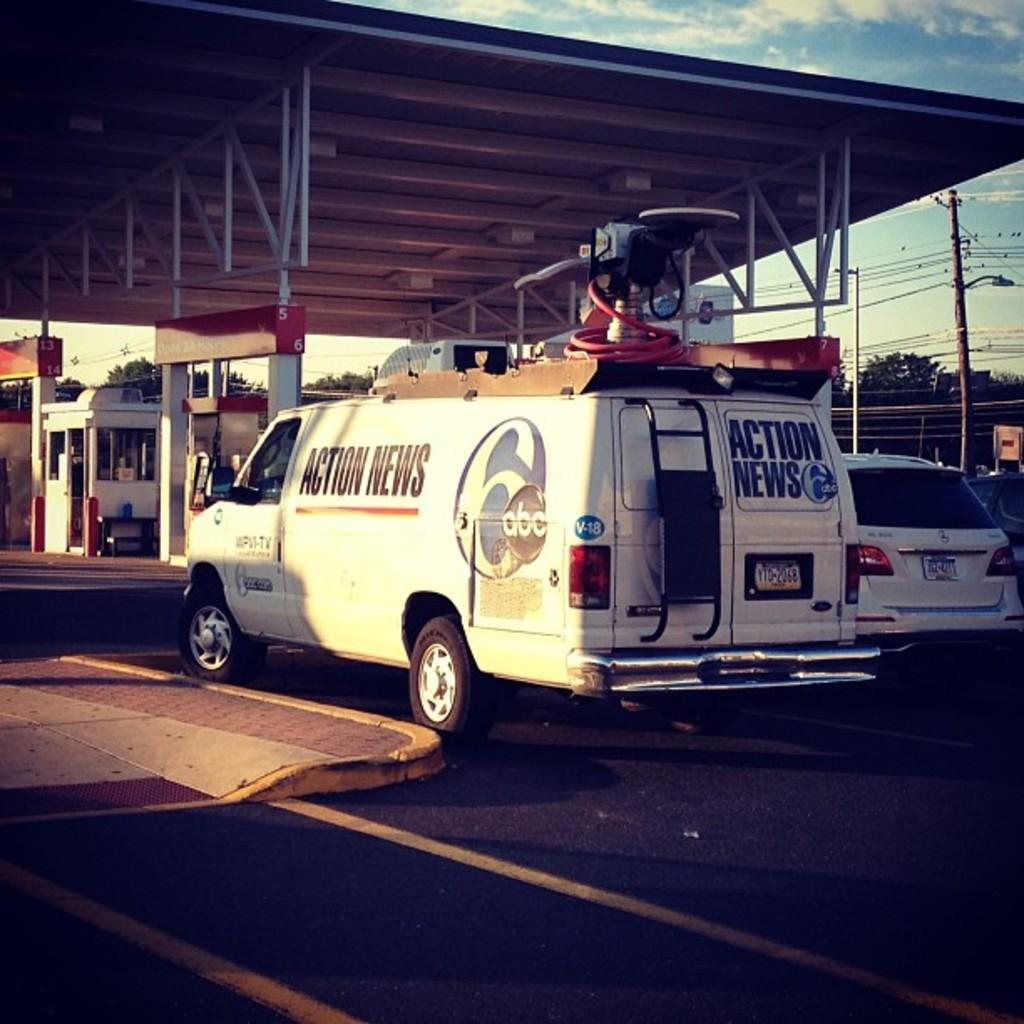<image>
Render a clear and concise summary of the photo. A white van from abc affiliate channel 6 and Action News written on it's side. 